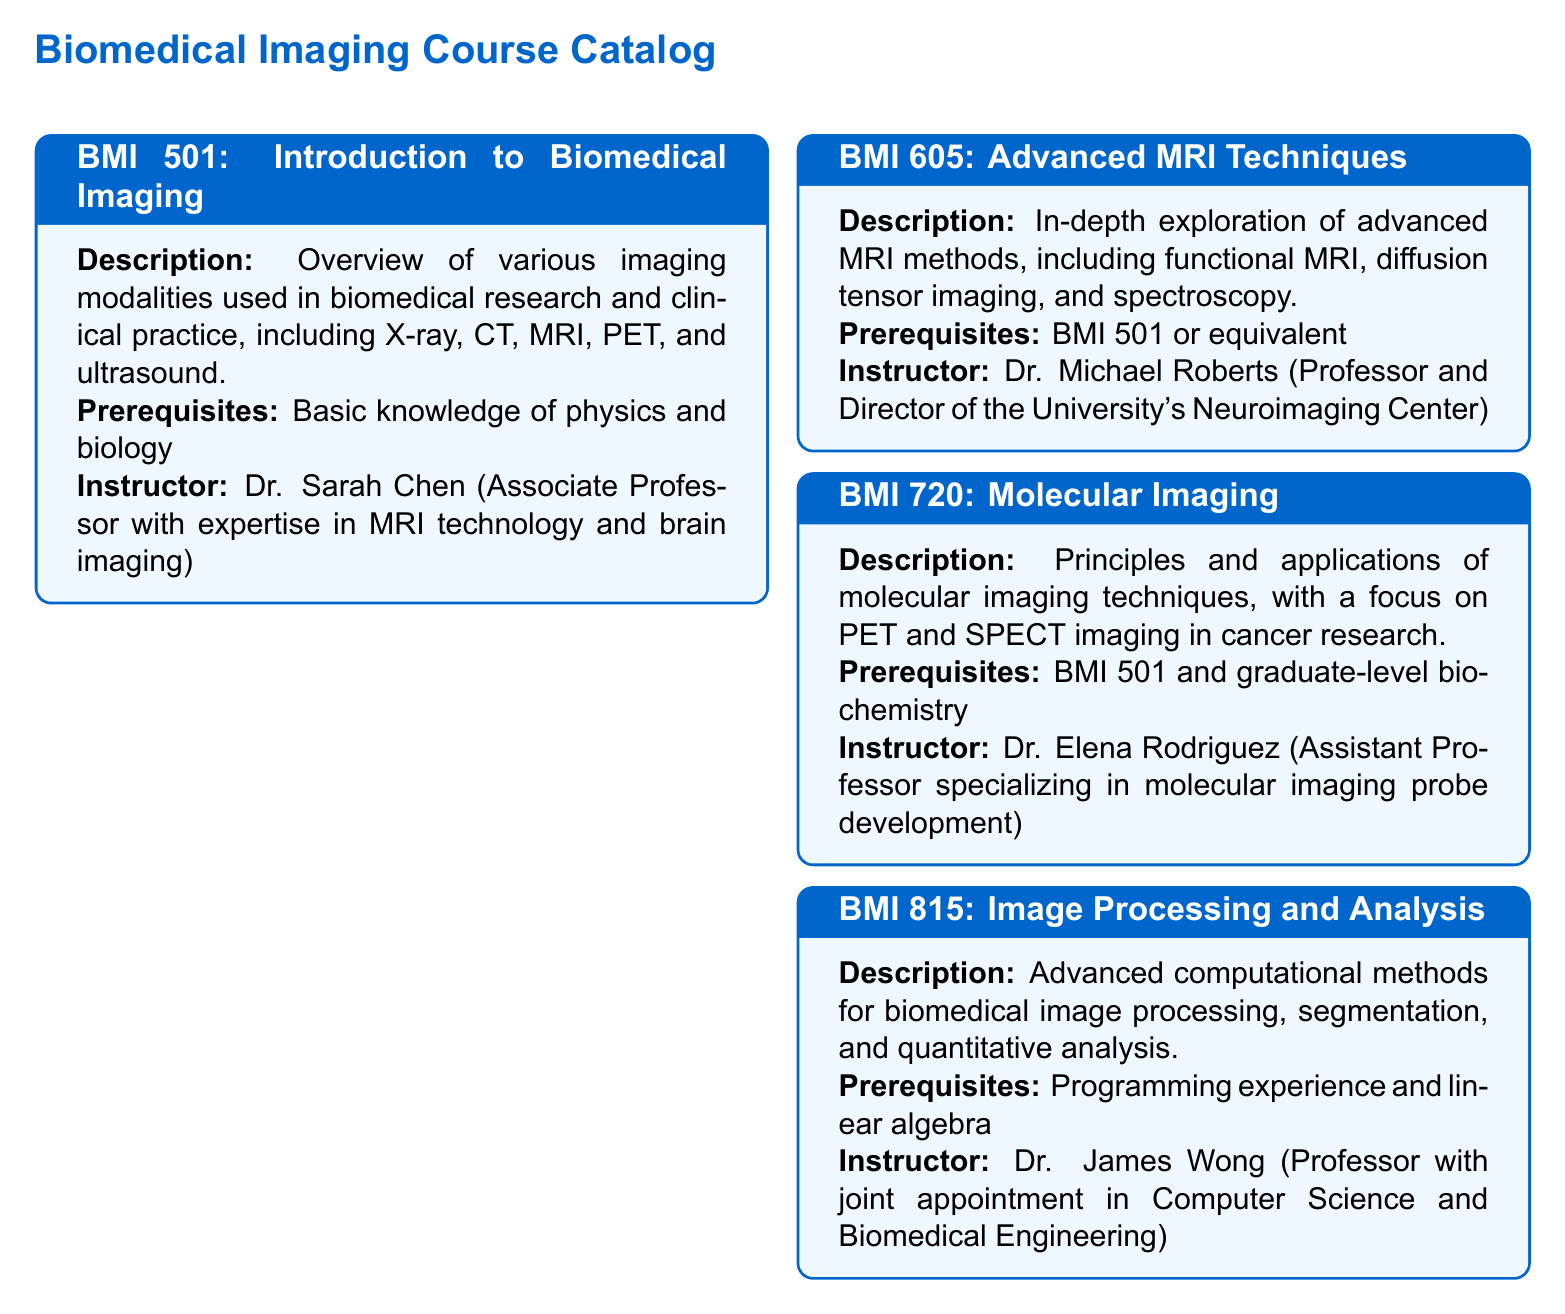What is the title of the first course in the catalog? The title of the first course is listed as "Introduction to Biomedical Imaging."
Answer: Introduction to Biomedical Imaging Who teaches the Advanced MRI Techniques course? The instructor for the Advanced MRI Techniques course is mentioned in the document.
Answer: Dr. Michael Roberts What are the prerequisites for the Molecular Imaging course? The prerequisites specified for the Molecular Imaging course are required knowledge areas.
Answer: BMI 501 and graduate-level biochemistry How many courses are listed in the catalog? The total number of courses can be counted based on the entries provided in the document.
Answer: 4 Which course focuses on advanced computational methods? The course that emphasizes advanced computational methods is distinctly described in the document.
Answer: Image Processing and Analysis What imaging modalities are covered in the Introduction to Biomedical Imaging course? The document outlines several modalities covered in the course description.
Answer: X-ray, CT, MRI, PET, and ultrasound Who specializes in molecular imaging probe development? The instructor for the Molecular Imaging course has a specialization noted in the document.
Answer: Dr. Elena Rodriguez What is the subject focus of BMI 815? The subject focus of BMI 815 is detailed in the title.
Answer: Image Processing and Analysis 